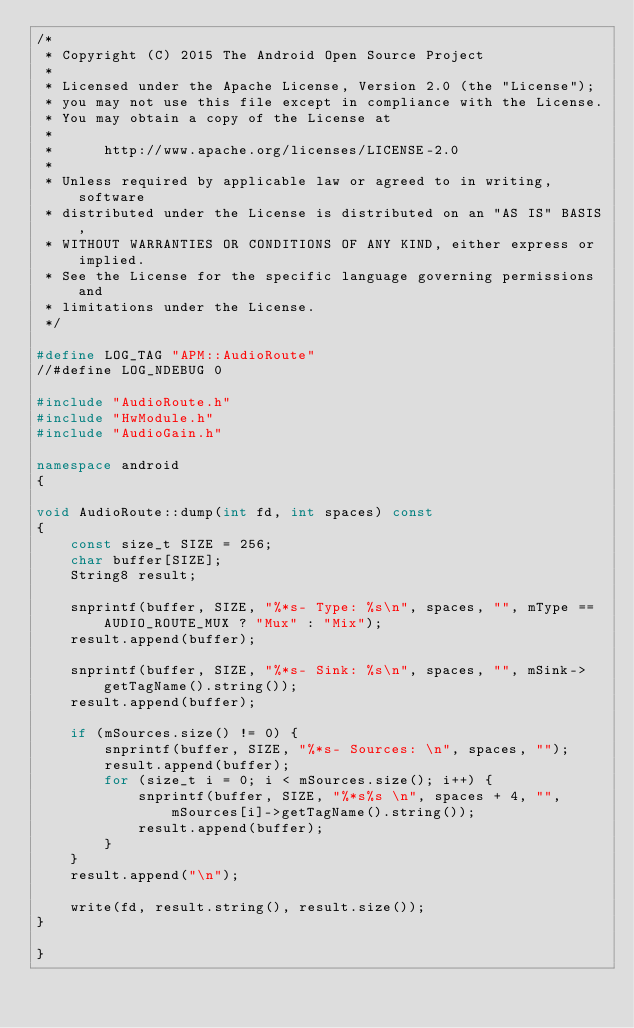<code> <loc_0><loc_0><loc_500><loc_500><_C++_>/*
 * Copyright (C) 2015 The Android Open Source Project
 *
 * Licensed under the Apache License, Version 2.0 (the "License");
 * you may not use this file except in compliance with the License.
 * You may obtain a copy of the License at
 *
 *      http://www.apache.org/licenses/LICENSE-2.0
 *
 * Unless required by applicable law or agreed to in writing, software
 * distributed under the License is distributed on an "AS IS" BASIS,
 * WITHOUT WARRANTIES OR CONDITIONS OF ANY KIND, either express or implied.
 * See the License for the specific language governing permissions and
 * limitations under the License.
 */

#define LOG_TAG "APM::AudioRoute"
//#define LOG_NDEBUG 0

#include "AudioRoute.h"
#include "HwModule.h"
#include "AudioGain.h"

namespace android
{

void AudioRoute::dump(int fd, int spaces) const
{
    const size_t SIZE = 256;
    char buffer[SIZE];
    String8 result;

    snprintf(buffer, SIZE, "%*s- Type: %s\n", spaces, "", mType == AUDIO_ROUTE_MUX ? "Mux" : "Mix");
    result.append(buffer);

    snprintf(buffer, SIZE, "%*s- Sink: %s\n", spaces, "", mSink->getTagName().string());
    result.append(buffer);

    if (mSources.size() != 0) {
        snprintf(buffer, SIZE, "%*s- Sources: \n", spaces, "");
        result.append(buffer);
        for (size_t i = 0; i < mSources.size(); i++) {
            snprintf(buffer, SIZE, "%*s%s \n", spaces + 4, "", mSources[i]->getTagName().string());
            result.append(buffer);
        }
    }
    result.append("\n");

    write(fd, result.string(), result.size());
}

}
</code> 